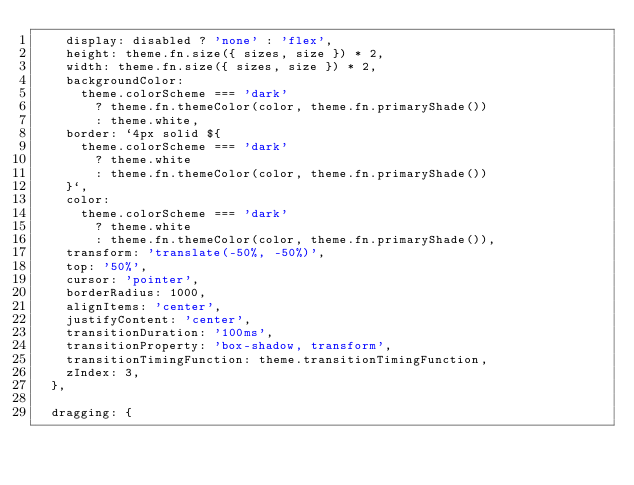<code> <loc_0><loc_0><loc_500><loc_500><_TypeScript_>    display: disabled ? 'none' : 'flex',
    height: theme.fn.size({ sizes, size }) * 2,
    width: theme.fn.size({ sizes, size }) * 2,
    backgroundColor:
      theme.colorScheme === 'dark'
        ? theme.fn.themeColor(color, theme.fn.primaryShade())
        : theme.white,
    border: `4px solid ${
      theme.colorScheme === 'dark'
        ? theme.white
        : theme.fn.themeColor(color, theme.fn.primaryShade())
    }`,
    color:
      theme.colorScheme === 'dark'
        ? theme.white
        : theme.fn.themeColor(color, theme.fn.primaryShade()),
    transform: 'translate(-50%, -50%)',
    top: '50%',
    cursor: 'pointer',
    borderRadius: 1000,
    alignItems: 'center',
    justifyContent: 'center',
    transitionDuration: '100ms',
    transitionProperty: 'box-shadow, transform',
    transitionTimingFunction: theme.transitionTimingFunction,
    zIndex: 3,
  },

  dragging: {</code> 